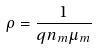<formula> <loc_0><loc_0><loc_500><loc_500>\rho = \frac { 1 } { q n _ { m } \mu _ { m } }</formula> 